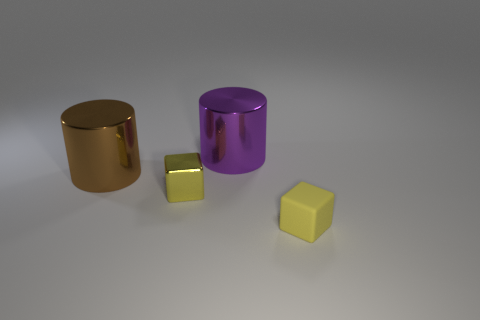Subtract 1 blocks. How many blocks are left? 1 Subtract all yellow cylinders. How many green cubes are left? 0 Subtract all tiny red blocks. Subtract all metal objects. How many objects are left? 1 Add 3 purple things. How many purple things are left? 4 Add 2 big brown matte cylinders. How many big brown matte cylinders exist? 2 Add 2 large metallic objects. How many objects exist? 6 Subtract 0 blue blocks. How many objects are left? 4 Subtract all purple cylinders. Subtract all green cubes. How many cylinders are left? 1 